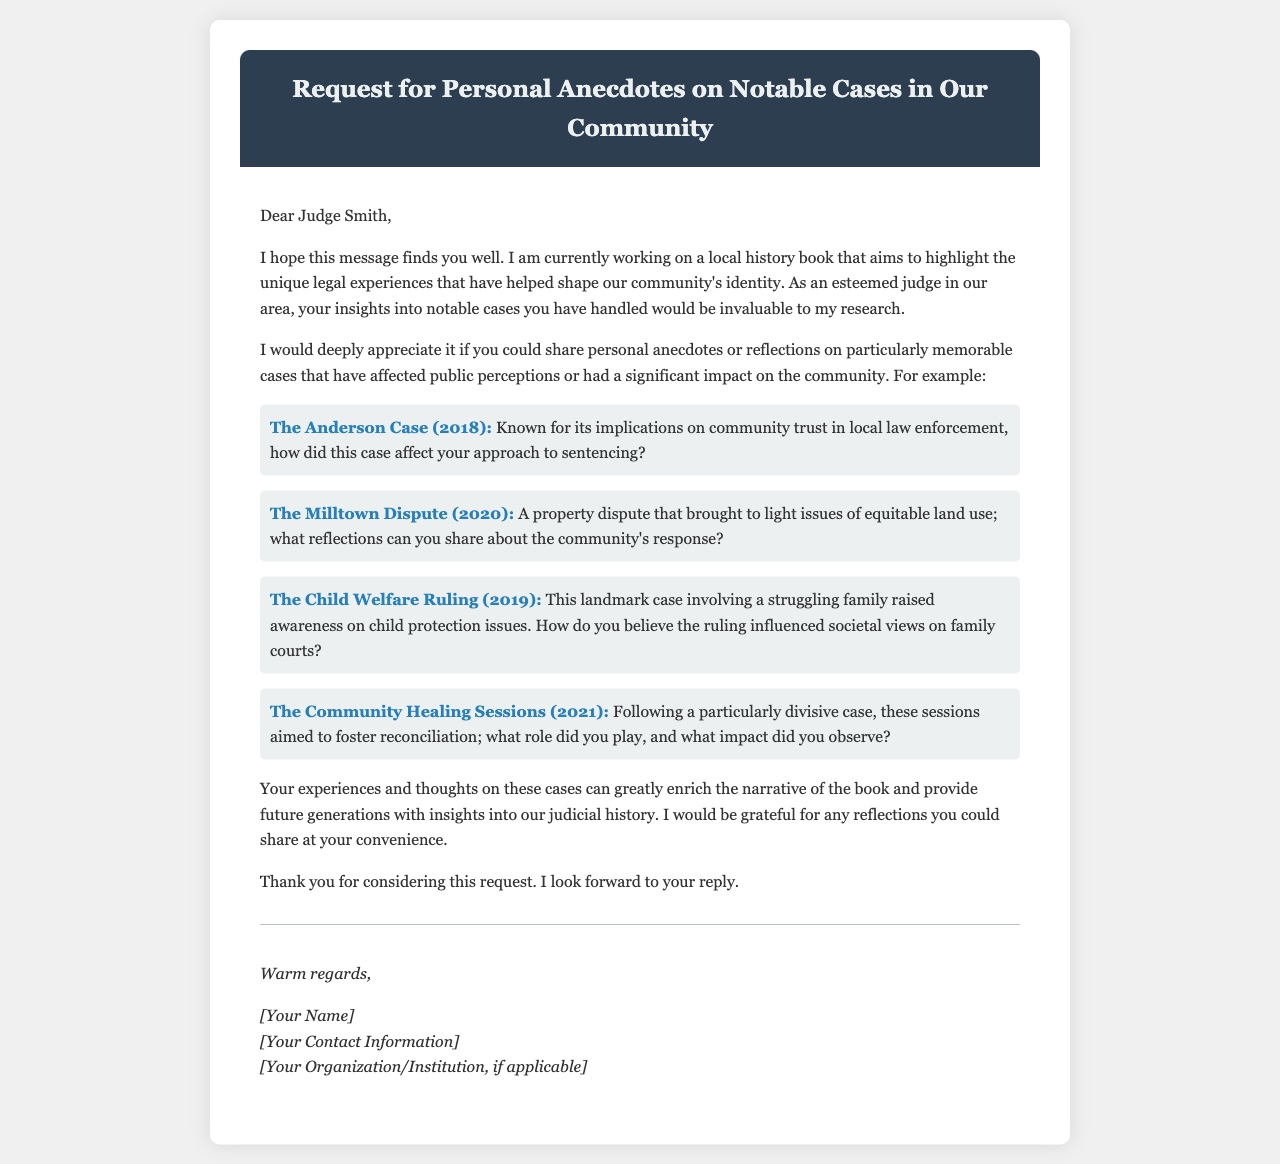what is the title of the email? The title of the email is presented in the header section, describing its main purpose.
Answer: Request for Personal Anecdotes on Notable Cases in Our Community who is the recipient of the email? The recipient's name is indicated in the salutation at the beginning of the email.
Answer: Judge Smith what year did the Child Welfare Ruling take place? The year is explicitly mentioned in the list of notable cases within the email.
Answer: 2019 name one case that raised issues of equitable land use. This information is found in the description of one of the notable cases discussed in the email.
Answer: The Milltown Dispute what was the purpose of the Community Healing Sessions? The purpose is identified in the context surrounding the notable case mentioned in the email.
Answer: To foster reconciliation how many notable cases are mentioned in the email? The number can be counted based on the cases listed in the document.
Answer: Four what sentiments does the author seek to capture about the cases? The author expresses a desire for personal reflections that indicate a deeper understanding of the cases' impacts.
Answer: Community perceptions who is the author of the email? The author's name is noted in the signature section of the email.
Answer: [Your Name] what type of document is this? The structure and content suggest the format of this document.
Answer: Email 